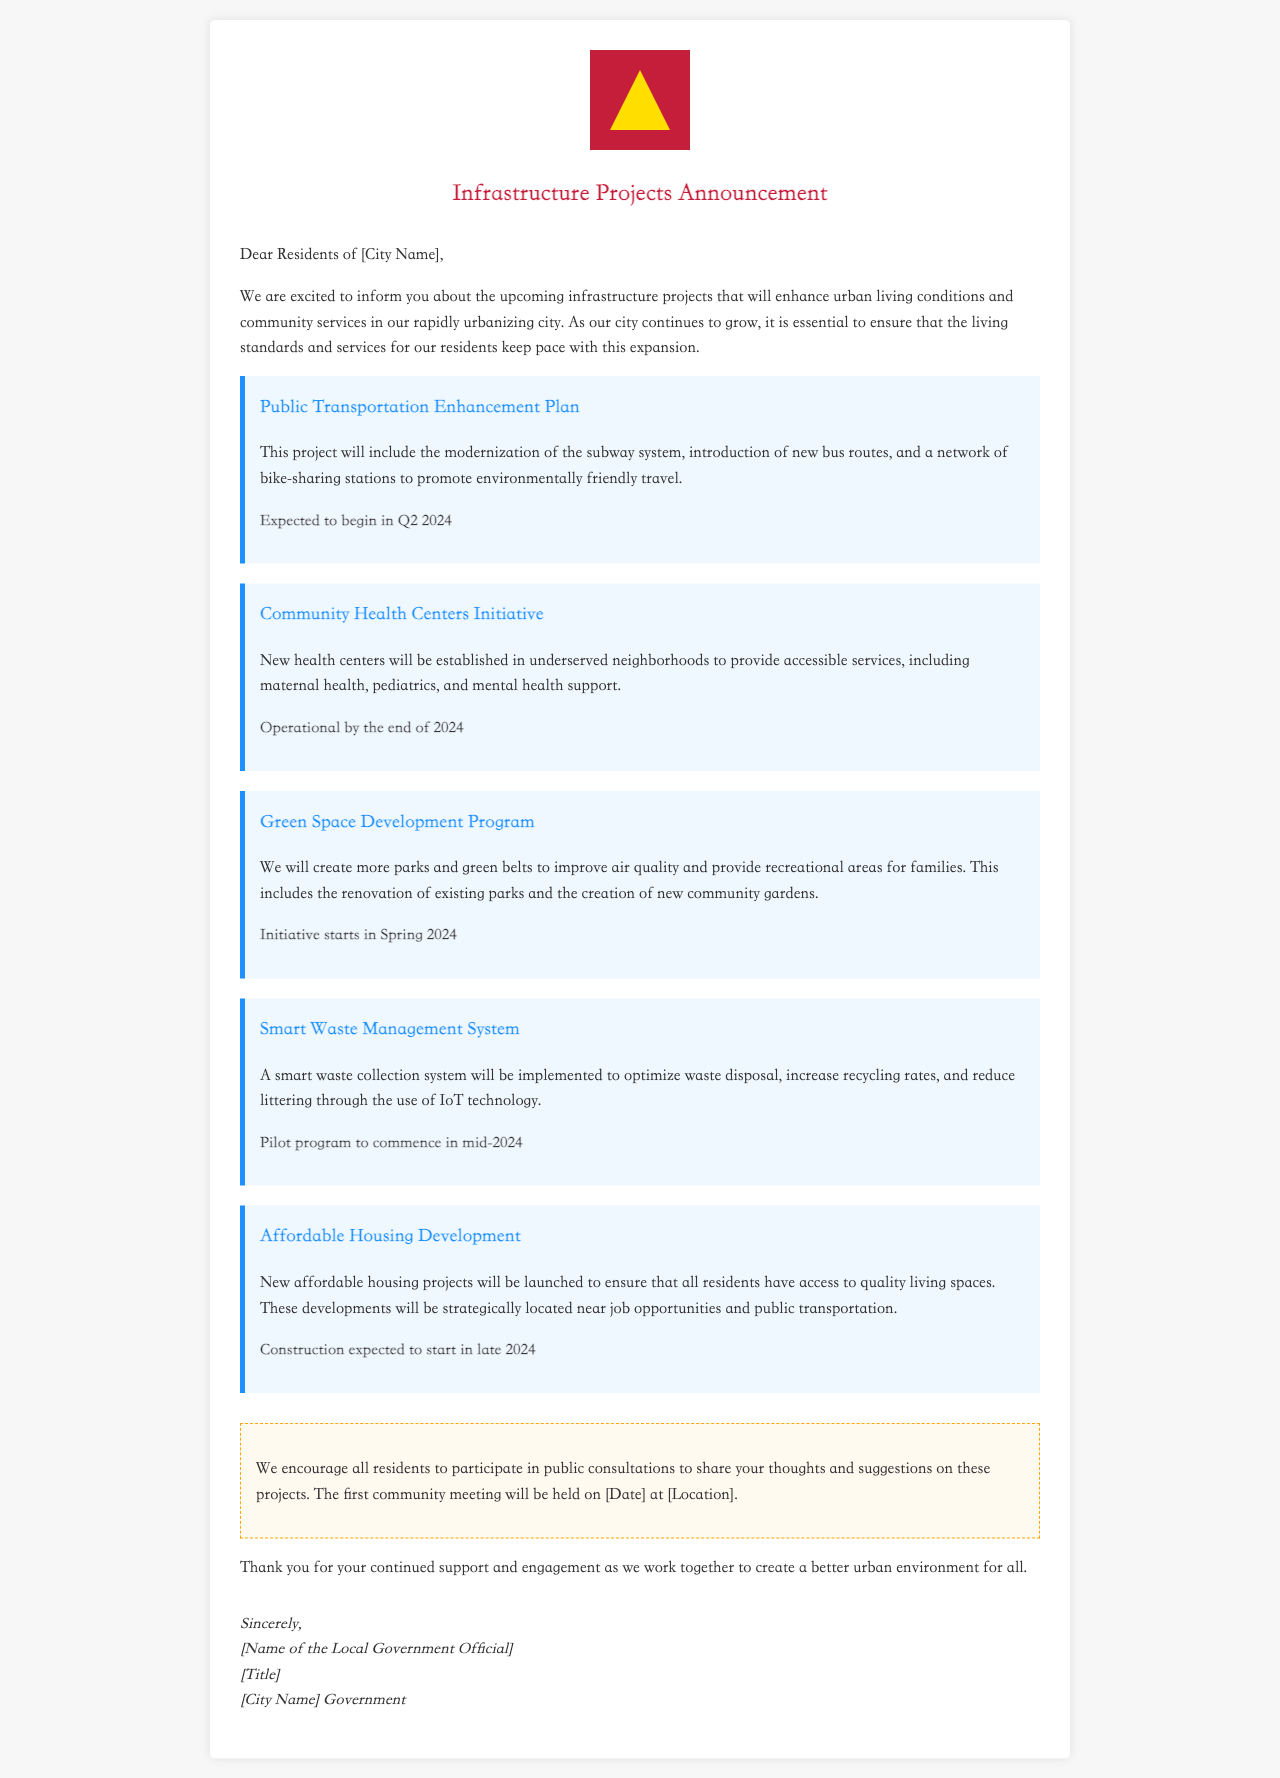What is the main focus of the new projects? The main focus is to enhance urban living conditions and community services in the city.
Answer: Urban living conditions and community services When is the Public Transportation Enhancement Plan expected to begin? The document states that this project is expected to begin in the second quarter of 2024.
Answer: Q2 2024 What type of medical services will the Community Health Centers Initiative provide? The new health centers will provide accessible services including maternal health, pediatrics, and mental health support.
Answer: Maternal health, pediatrics, and mental health support What environmental benefit is associated with the Green Space Development Program? The program aims to improve air quality and provide recreational areas for families through the creation of more parks and green belts.
Answer: Improve air quality When is the pilot program for the Smart Waste Management System set to commence? The pilot program is scheduled to commence in mid-2024 according to the document.
Answer: Mid-2024 What is the purpose of the Affordable Housing Development? The purpose is to ensure that all residents have access to quality living spaces near job opportunities and public transportation.
Answer: Access to quality living spaces What should residents do to share their thoughts on the projects? Residents are encouraged to participate in public consultations to share their thoughts and suggestions.
Answer: Participate in public consultations Who signed the letter? The document mentions that the letter is signed by the local government official, but the specific name is represented as a placeholder.
Answer: [Name of the Local Government Official] 